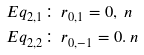<formula> <loc_0><loc_0><loc_500><loc_500>E q _ { 2 , 1 } \colon \, & r _ { 0 , 1 } = 0 , \ n \\ E q _ { 2 , 2 } \colon \, & r _ { 0 , - 1 } = 0 . \ n</formula> 